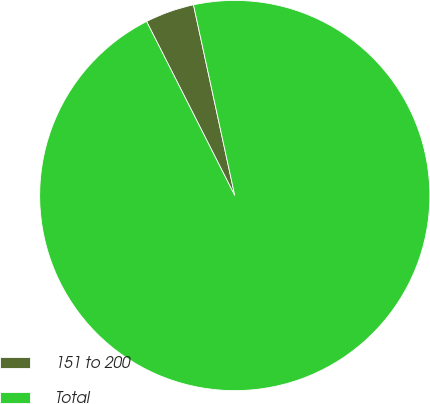Convert chart to OTSL. <chart><loc_0><loc_0><loc_500><loc_500><pie_chart><fcel>151 to 200<fcel>Total<nl><fcel>4.07%<fcel>95.93%<nl></chart> 